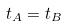Convert formula to latex. <formula><loc_0><loc_0><loc_500><loc_500>t _ { A } = t _ { B }</formula> 